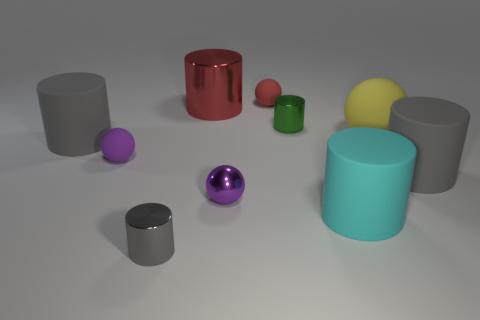Subtract all yellow balls. How many balls are left? 3 Subtract all tiny cylinders. How many cylinders are left? 4 Subtract all red cylinders. How many red spheres are left? 1 Subtract all cylinders. Subtract all small cyan blocks. How many objects are left? 4 Add 3 rubber cylinders. How many rubber cylinders are left? 6 Add 6 big brown matte spheres. How many big brown matte spheres exist? 6 Subtract 0 purple blocks. How many objects are left? 10 Subtract all cylinders. How many objects are left? 4 Subtract 2 balls. How many balls are left? 2 Subtract all purple cylinders. Subtract all brown cubes. How many cylinders are left? 6 